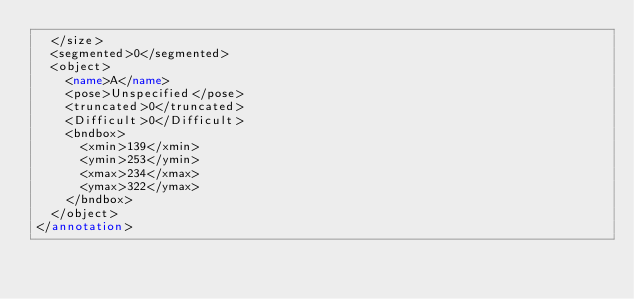Convert code to text. <code><loc_0><loc_0><loc_500><loc_500><_XML_>  </size>
  <segmented>0</segmented>
  <object>
    <name>A</name>
    <pose>Unspecified</pose>
    <truncated>0</truncated>
    <Difficult>0</Difficult>
    <bndbox>
      <xmin>139</xmin>
      <ymin>253</ymin>
      <xmax>234</xmax>
      <ymax>322</ymax>
    </bndbox>
  </object>
</annotation></code> 